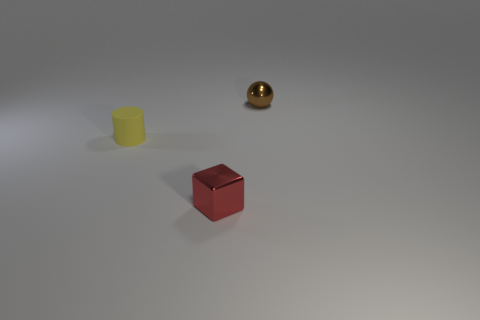Subtract all cylinders. How many objects are left? 2 Subtract 1 cubes. How many cubes are left? 0 Subtract all large cyan rubber cylinders. Subtract all tiny shiny spheres. How many objects are left? 2 Add 1 brown things. How many brown things are left? 2 Add 3 metallic spheres. How many metallic spheres exist? 4 Add 3 yellow cylinders. How many objects exist? 6 Subtract 0 red spheres. How many objects are left? 3 